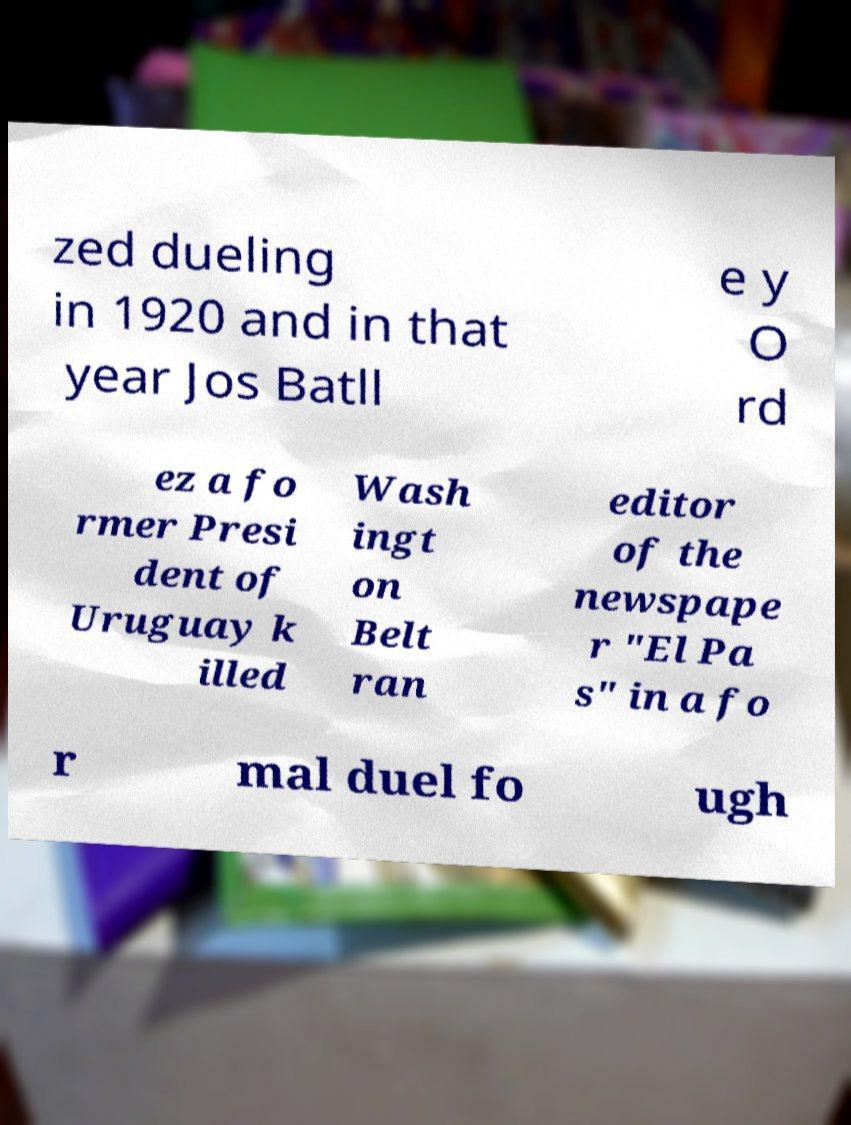I need the written content from this picture converted into text. Can you do that? zed dueling in 1920 and in that year Jos Batll e y O rd ez a fo rmer Presi dent of Uruguay k illed Wash ingt on Belt ran editor of the newspape r "El Pa s" in a fo r mal duel fo ugh 